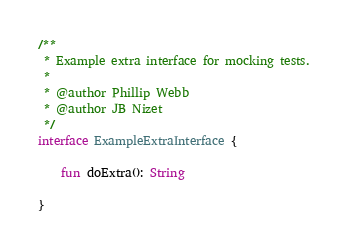Convert code to text. <code><loc_0><loc_0><loc_500><loc_500><_Kotlin_>/**
 * Example extra interface for mocking tests.
 *
 * @author Phillip Webb
 * @author JB Nizet
 */
interface ExampleExtraInterface {

    fun doExtra(): String

}
</code> 